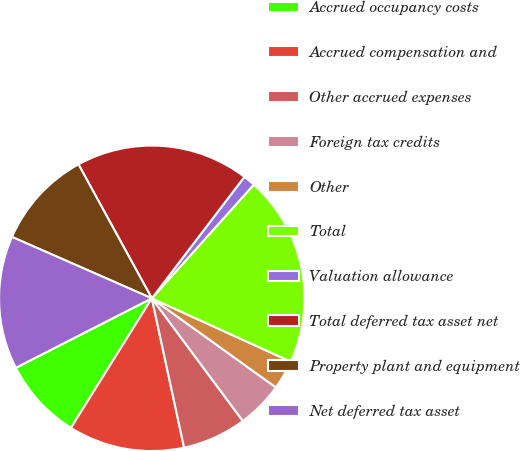Convert chart to OTSL. <chart><loc_0><loc_0><loc_500><loc_500><pie_chart><fcel>Accrued occupancy costs<fcel>Accrued compensation and<fcel>Other accrued expenses<fcel>Foreign tax credits<fcel>Other<fcel>Total<fcel>Valuation allowance<fcel>Total deferred tax asset net<fcel>Property plant and equipment<fcel>Net deferred tax asset<nl><fcel>8.6%<fcel>12.27%<fcel>6.77%<fcel>4.93%<fcel>3.1%<fcel>20.17%<fcel>1.27%<fcel>18.34%<fcel>10.44%<fcel>14.1%<nl></chart> 